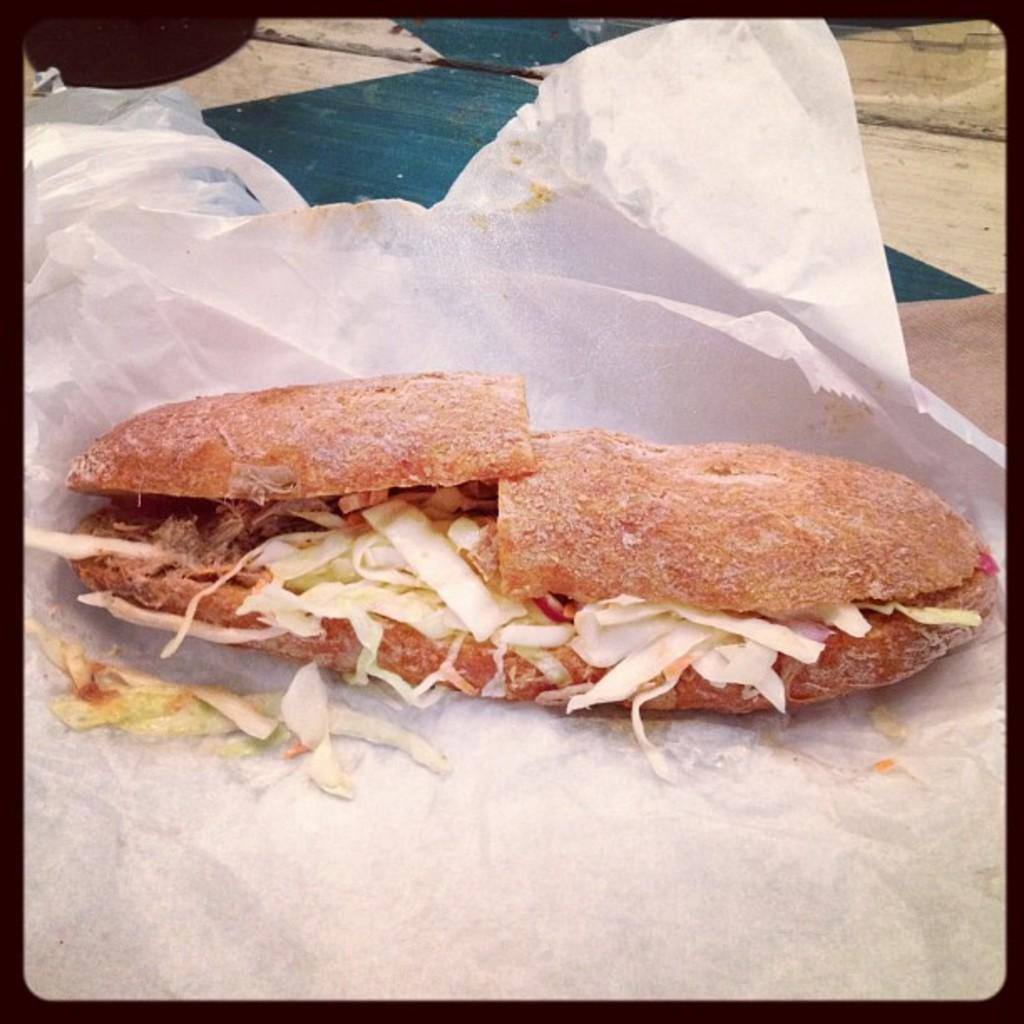What is the main subject of the image? The main subject of the image is a picture of a stuffed sandwich. Where is the picture located? The picture is on a tissue. What type of train can be seen passing by in the image? There is no train present in the image; it only features a picture of a stuffed sandwich on a tissue. How many stars are visible in the image? There are no stars visible in the image, as it only contains a picture of a stuffed sandwich on a tissue. 